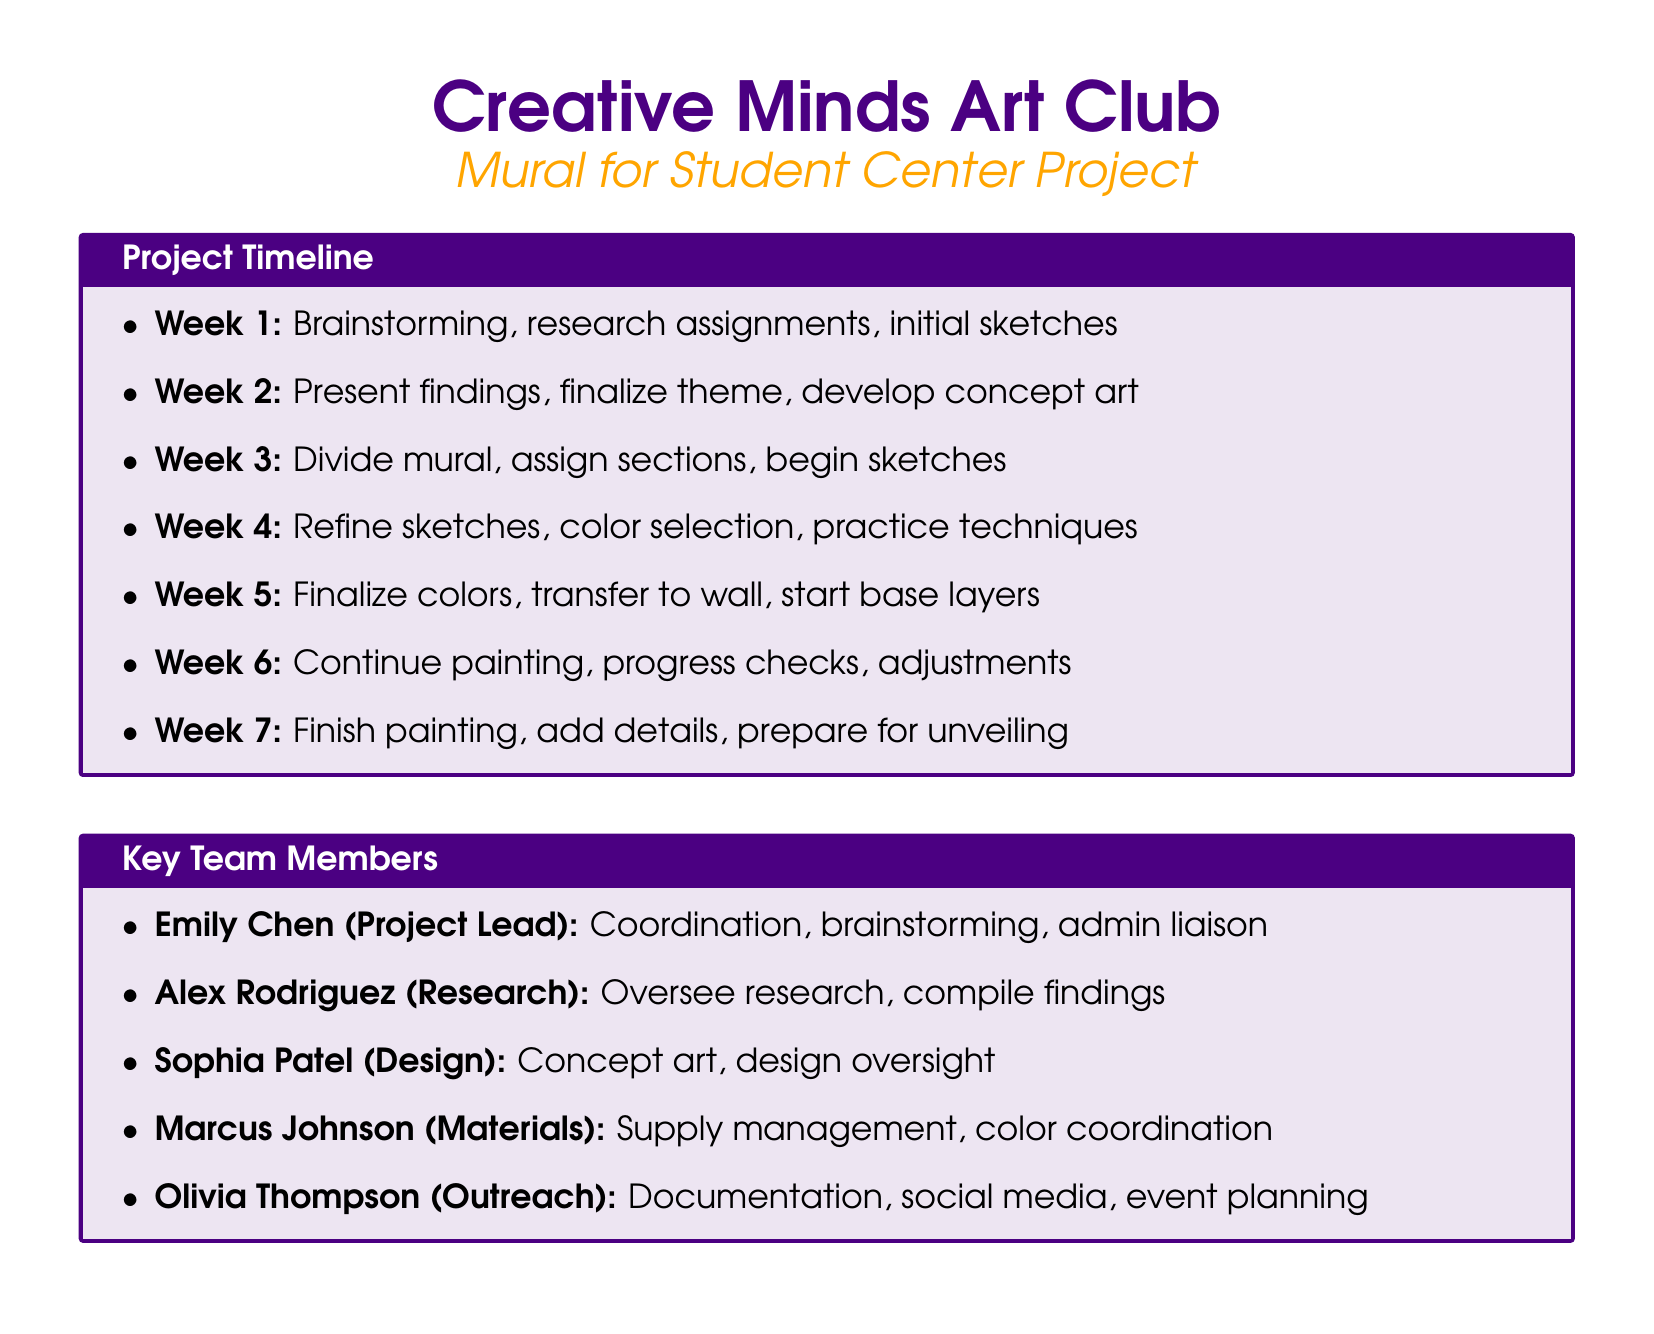What is the project title? The project title is mentioned in the club's agenda, which is "Mural for Student Center."
Answer: Mural for Student Center How many weeks does the project timeline cover? The project timeline is divided into seven weeks, each with its own set of tasks.
Answer: Seven weeks Who is the Project Lead? The role of Project Lead is assigned to Emily Chen, as per the task assignments.
Answer: Emily Chen What day of the week are meetings held? The meetings for the club are scheduled for Wednesdays based on the meeting schedule provided.
Answer: Wednesdays Which technique is included for this project? The document lists various techniques, and one of them is "Mural painting techniques."
Answer: Mural painting techniques What is one responsibility of the Outreach Coordinator? The responsibilities of the Outreach Coordinator, Olivia Thompson, include documenting project progress.
Answer: Document project progress What are members expected to do in week 3? In week 3, the tasks include dividing the mural into sections and assigning them to team members.
Answer: Divide mural into sections How long are the meetings scheduled for? The meetings are scheduled for a specific time frame as stated in the document.
Answer: Two hours 